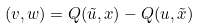<formula> <loc_0><loc_0><loc_500><loc_500>( v , w ) = Q ( \tilde { u } , x ) - Q ( u , \tilde { x } )</formula> 